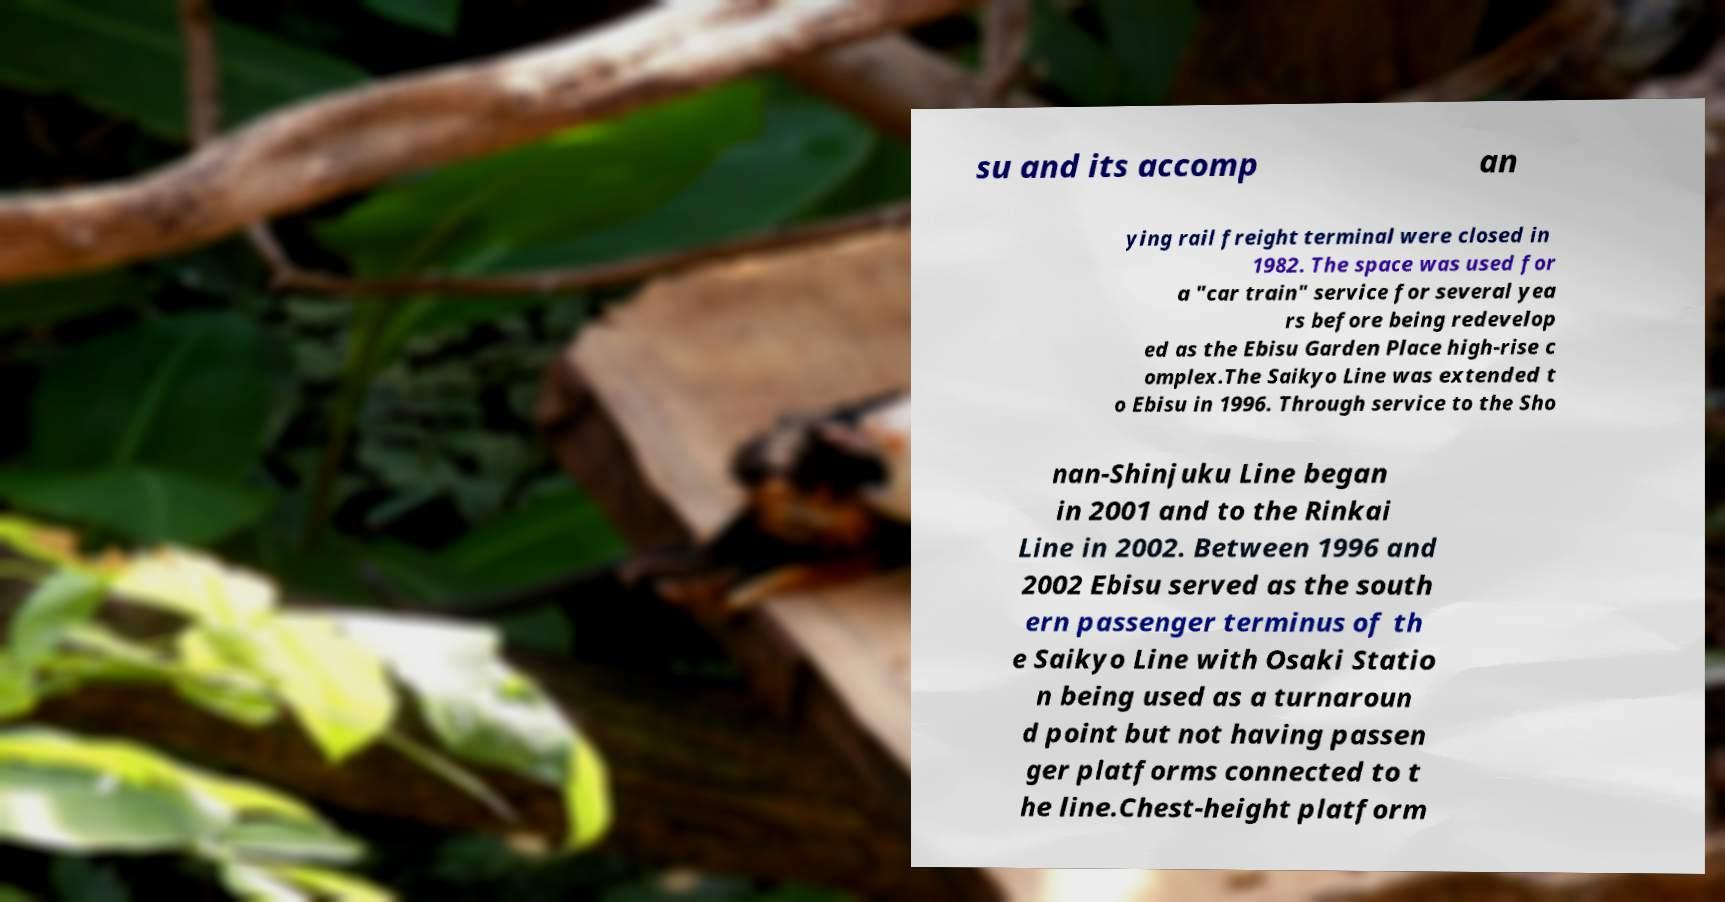There's text embedded in this image that I need extracted. Can you transcribe it verbatim? su and its accomp an ying rail freight terminal were closed in 1982. The space was used for a "car train" service for several yea rs before being redevelop ed as the Ebisu Garden Place high-rise c omplex.The Saikyo Line was extended t o Ebisu in 1996. Through service to the Sho nan-Shinjuku Line began in 2001 and to the Rinkai Line in 2002. Between 1996 and 2002 Ebisu served as the south ern passenger terminus of th e Saikyo Line with Osaki Statio n being used as a turnaroun d point but not having passen ger platforms connected to t he line.Chest-height platform 